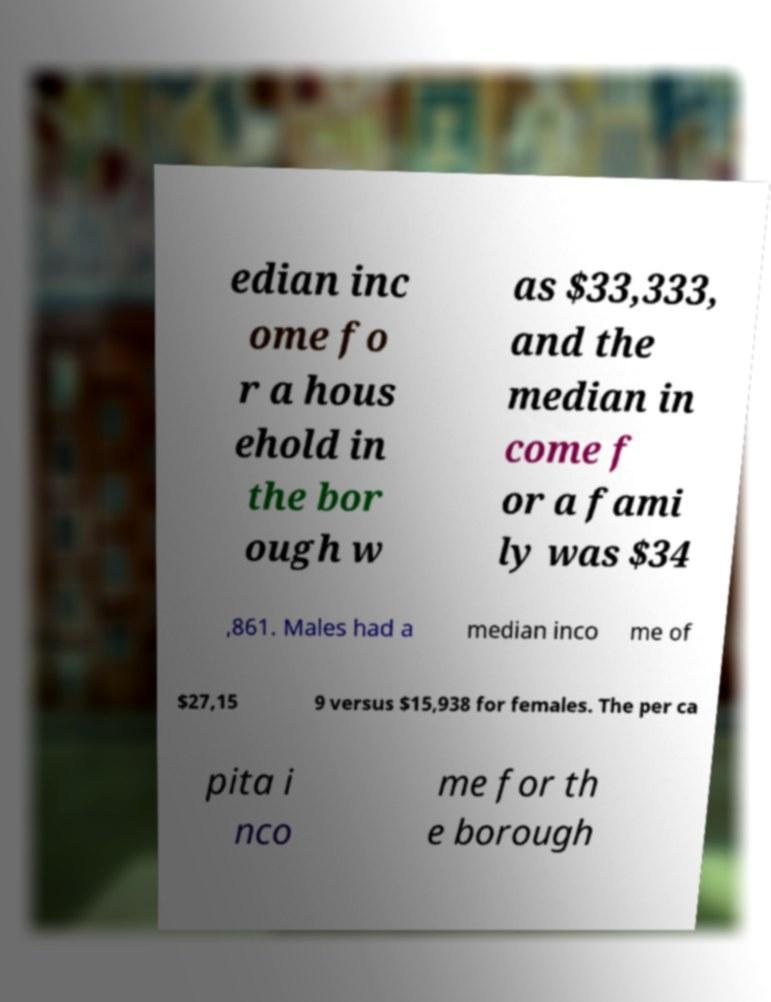Can you read and provide the text displayed in the image?This photo seems to have some interesting text. Can you extract and type it out for me? edian inc ome fo r a hous ehold in the bor ough w as $33,333, and the median in come f or a fami ly was $34 ,861. Males had a median inco me of $27,15 9 versus $15,938 for females. The per ca pita i nco me for th e borough 